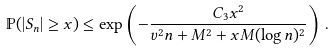Convert formula to latex. <formula><loc_0><loc_0><loc_500><loc_500>\mathbb { P } ( | S _ { n } | \geq x ) \leq \exp \left ( - { \frac { C _ { 3 } x ^ { 2 } } { v ^ { 2 } n + M ^ { 2 } + x M ( \log n ) ^ { 2 } } } \right ) \, .</formula> 